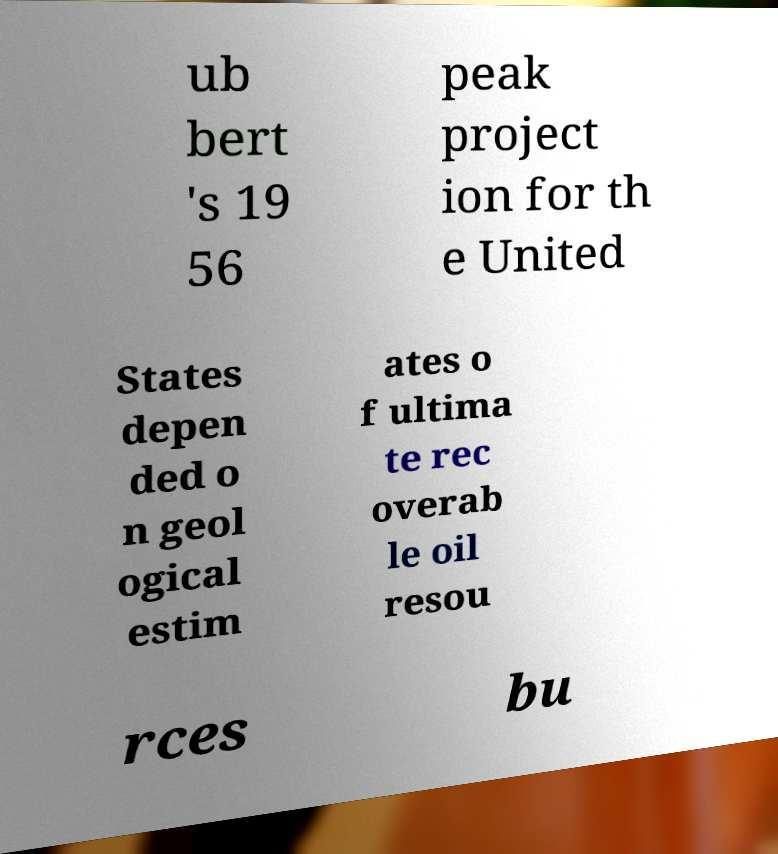There's text embedded in this image that I need extracted. Can you transcribe it verbatim? ub bert 's 19 56 peak project ion for th e United States depen ded o n geol ogical estim ates o f ultima te rec overab le oil resou rces bu 